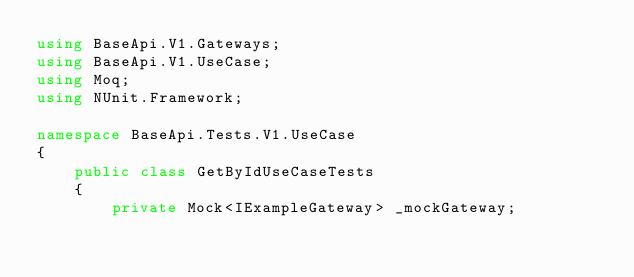<code> <loc_0><loc_0><loc_500><loc_500><_C#_>using BaseApi.V1.Gateways;
using BaseApi.V1.UseCase;
using Moq;
using NUnit.Framework;

namespace BaseApi.Tests.V1.UseCase
{
    public class GetByIdUseCaseTests
    {
        private Mock<IExampleGateway> _mockGateway;</code> 